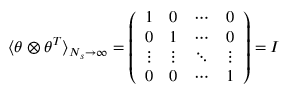<formula> <loc_0><loc_0><loc_500><loc_500>\langle \theta \otimes \theta ^ { T } \rangle _ { N _ { s } \to \infty } = \left ( \begin{array} { l l l l } { 1 } & { 0 } & { \cdots } & { 0 } \\ { 0 } & { 1 } & { \cdots } & { 0 } \\ { \vdots } & { \vdots } & { \ddots } & { \vdots } \\ { 0 } & { 0 } & { \cdots } & { 1 } \end{array} \right ) = I</formula> 